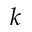<formula> <loc_0><loc_0><loc_500><loc_500>k</formula> 